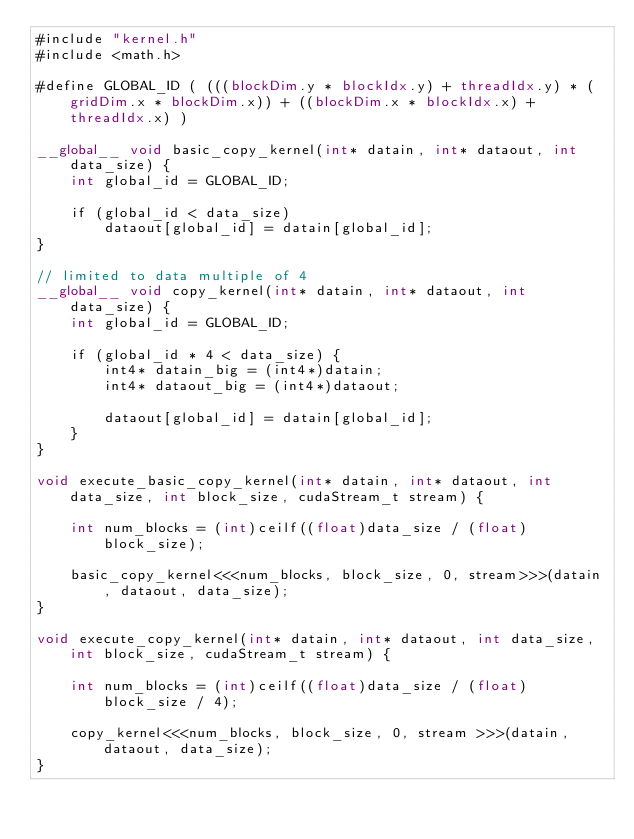<code> <loc_0><loc_0><loc_500><loc_500><_Cuda_>#include "kernel.h"
#include <math.h>

#define GLOBAL_ID ( (((blockDim.y * blockIdx.y) + threadIdx.y) * (gridDim.x * blockDim.x)) + ((blockDim.x * blockIdx.x) + threadIdx.x) )

__global__ void basic_copy_kernel(int* datain, int* dataout, int data_size) {
	int global_id = GLOBAL_ID;

	if (global_id < data_size)
		dataout[global_id] = datain[global_id];
}

// limited to data multiple of 4
__global__ void copy_kernel(int* datain, int* dataout, int data_size) {
	int global_id = GLOBAL_ID;

	if (global_id * 4 < data_size) {
		int4* datain_big = (int4*)datain;
		int4* dataout_big = (int4*)dataout;

		dataout[global_id] = datain[global_id];
	}
}

void execute_basic_copy_kernel(int* datain, int* dataout, int data_size, int block_size, cudaStream_t stream) {

	int num_blocks = (int)ceilf((float)data_size / (float)block_size);

	basic_copy_kernel<<<num_blocks, block_size, 0, stream>>>(datain, dataout, data_size);
}

void execute_copy_kernel(int* datain, int* dataout, int data_size, int block_size, cudaStream_t stream) {

	int num_blocks = (int)ceilf((float)data_size / (float)block_size / 4);

	copy_kernel<<<num_blocks, block_size, 0, stream >>>(datain, dataout, data_size);
}</code> 